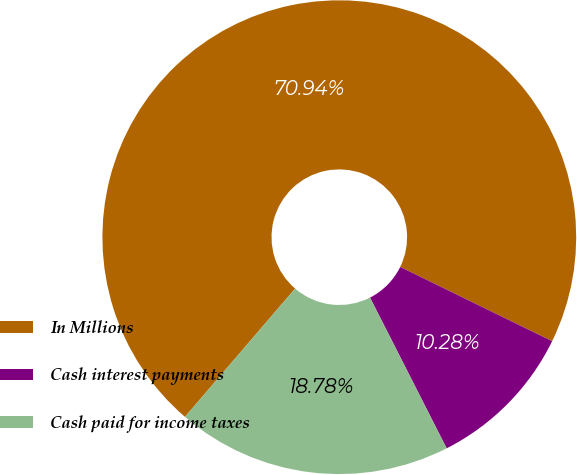Convert chart. <chart><loc_0><loc_0><loc_500><loc_500><pie_chart><fcel>In Millions<fcel>Cash interest payments<fcel>Cash paid for income taxes<nl><fcel>70.94%<fcel>10.28%<fcel>18.78%<nl></chart> 